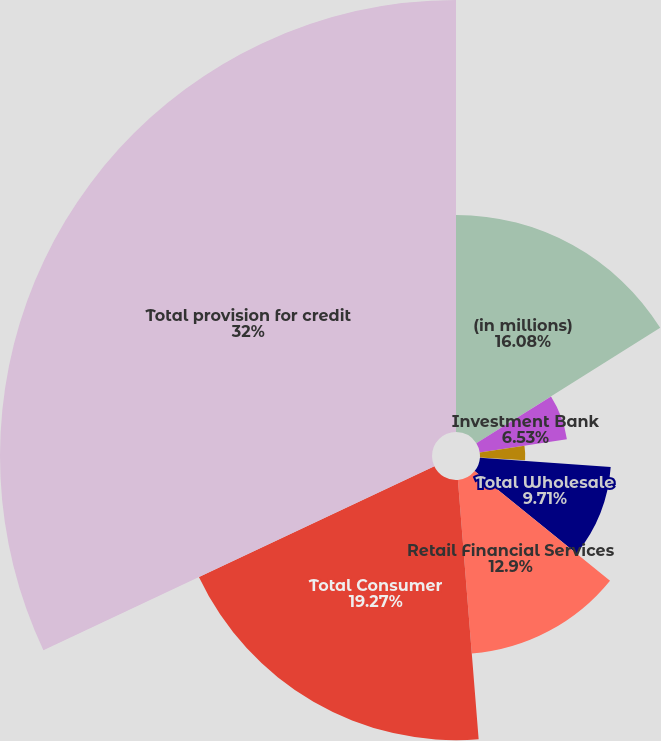<chart> <loc_0><loc_0><loc_500><loc_500><pie_chart><fcel>(in millions)<fcel>Investment Bank<fcel>Commercial Banking<fcel>Asset Management<fcel>Total Wholesale<fcel>Retail Financial Services<fcel>Total Consumer<fcel>Total provision for credit<nl><fcel>16.08%<fcel>6.53%<fcel>3.35%<fcel>0.16%<fcel>9.71%<fcel>12.9%<fcel>19.27%<fcel>32.0%<nl></chart> 